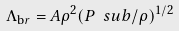Convert formula to latex. <formula><loc_0><loc_0><loc_500><loc_500>\Lambda _ { \mathrm b r } = A \rho ^ { 2 } ( P \ s u b / \rho ) ^ { 1 / 2 }</formula> 